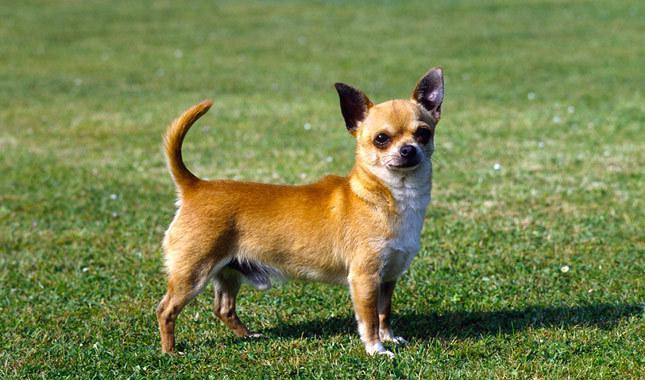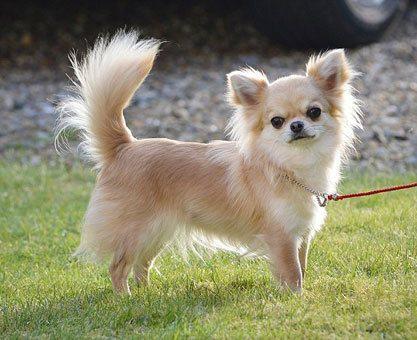The first image is the image on the left, the second image is the image on the right. Considering the images on both sides, is "At least one image shows a small dog standing on green grass." valid? Answer yes or no. Yes. 